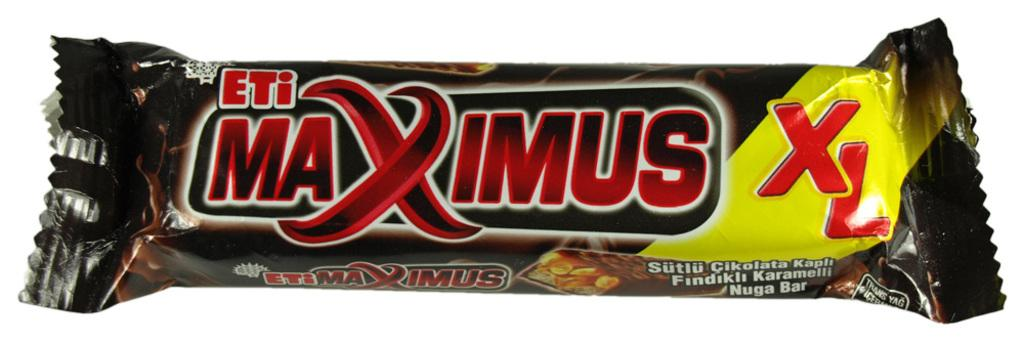What type of food item is present in the image? There is a chocolate bar in the image. What color is the wrapper of the chocolate bar? The wrapper of the chocolate bar is in brown color. Are there any words or information on the wrapper? Yes, there is text on the wrapper. What color is the background of the image? The background of the image is white. How does the chocolate bar spy on people in the image? The chocolate bar does not spy on people in the image; it is an inanimate object. 